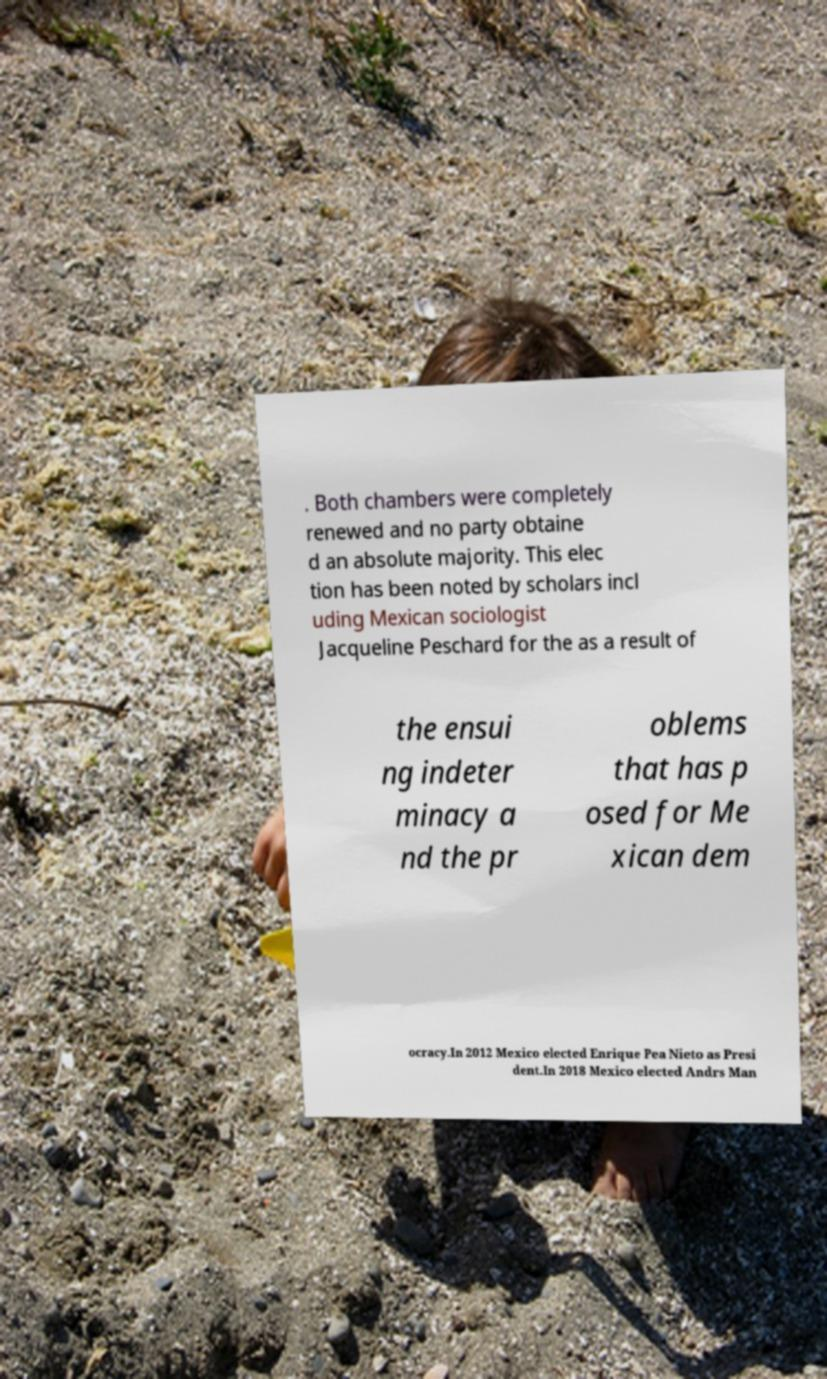Can you read and provide the text displayed in the image?This photo seems to have some interesting text. Can you extract and type it out for me? . Both chambers were completely renewed and no party obtaine d an absolute majority. This elec tion has been noted by scholars incl uding Mexican sociologist Jacqueline Peschard for the as a result of the ensui ng indeter minacy a nd the pr oblems that has p osed for Me xican dem ocracy.In 2012 Mexico elected Enrique Pea Nieto as Presi dent.In 2018 Mexico elected Andrs Man 